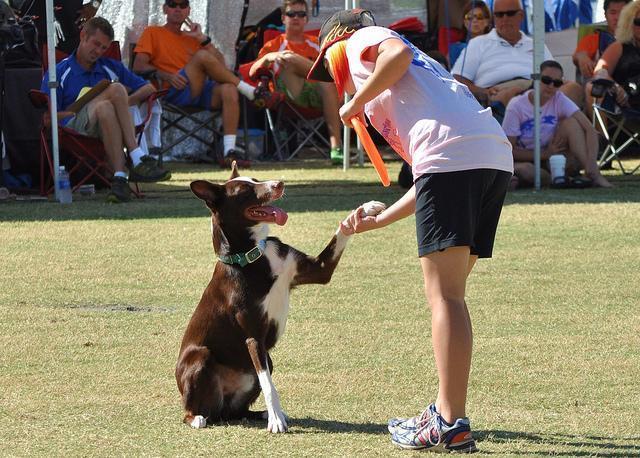How many people are there?
Give a very brief answer. 8. How many chairs are visible?
Give a very brief answer. 3. 